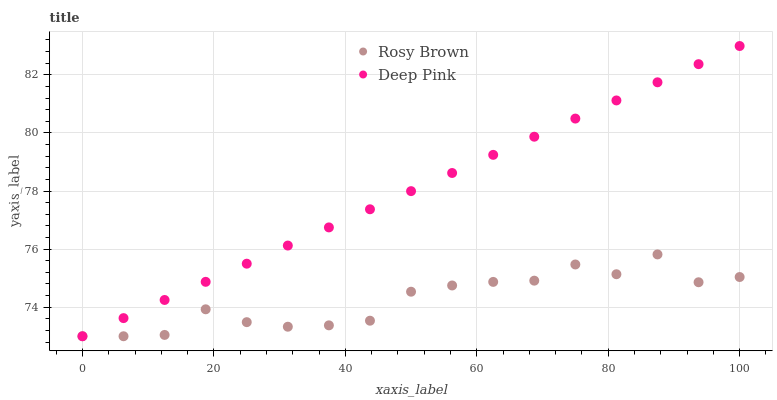Does Rosy Brown have the minimum area under the curve?
Answer yes or no. Yes. Does Deep Pink have the maximum area under the curve?
Answer yes or no. Yes. Does Deep Pink have the minimum area under the curve?
Answer yes or no. No. Is Deep Pink the smoothest?
Answer yes or no. Yes. Is Rosy Brown the roughest?
Answer yes or no. Yes. Is Deep Pink the roughest?
Answer yes or no. No. Does Rosy Brown have the lowest value?
Answer yes or no. Yes. Does Deep Pink have the highest value?
Answer yes or no. Yes. Does Rosy Brown intersect Deep Pink?
Answer yes or no. Yes. Is Rosy Brown less than Deep Pink?
Answer yes or no. No. Is Rosy Brown greater than Deep Pink?
Answer yes or no. No. 